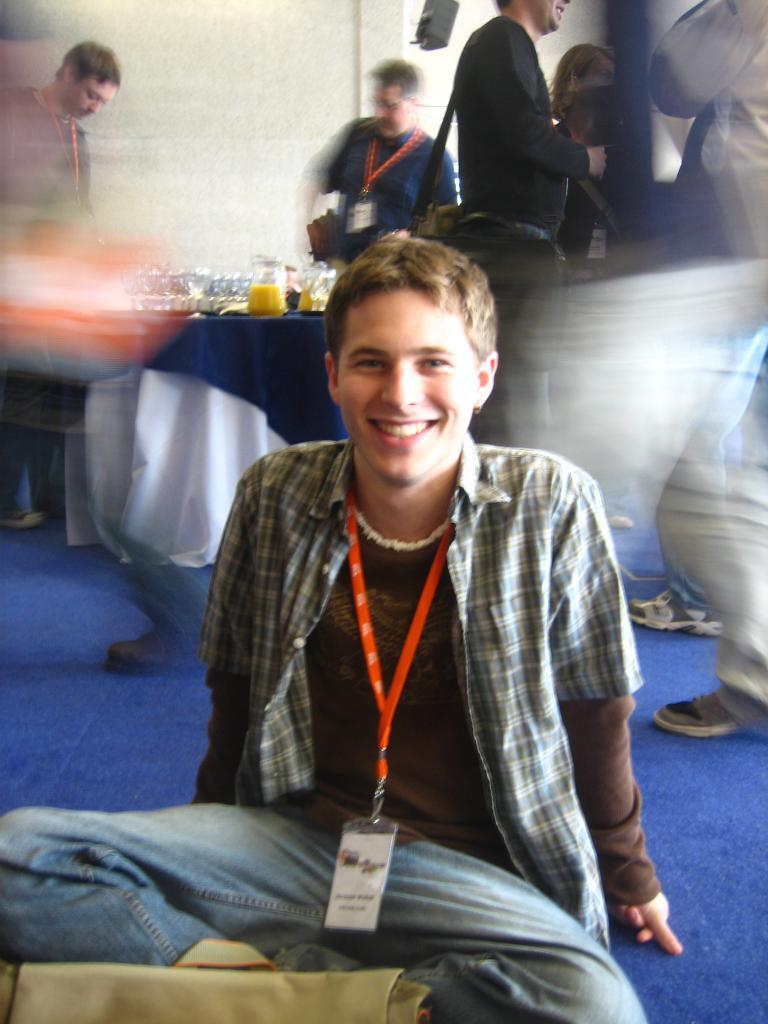Who is the main subject in the image? There is a boy in the center of the image. What is the boy doing in the image? The boy is sitting on the floor. Can you describe the background of the image? There are other people and a table in the background of the image. What type of health benefits does the toy in the image provide? There is no toy present in the image, so it is not possible to discuss any health benefits. 